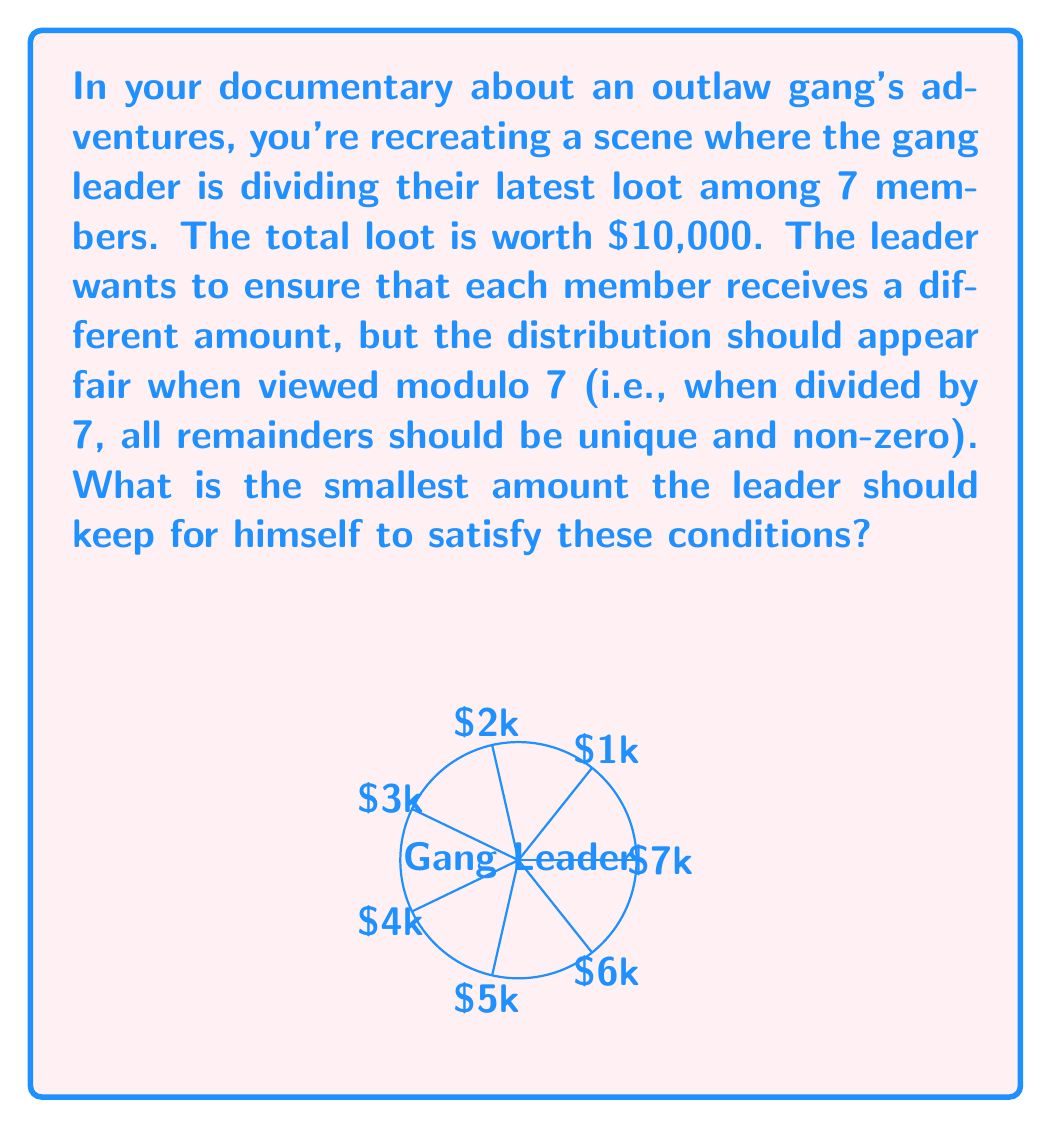What is the answer to this math problem? Let's approach this step-by-step:

1) We need to distribute amounts that, when divided by 7, give unique non-zero remainders. In modular arithmetic, this is expressed as:

   $$x_i \equiv i \pmod{7}, \text{ where } i = 1, 2, 3, 4, 5, 6$$

2) The smallest numbers that satisfy this are:

   $$x_1 = 1, x_2 = 2, x_3 = 3, x_4 = 4, x_5 = 5, x_6 = 6$$

3) However, we're dealing with dollars, so we need to scale these up. The smallest scale factor that works is 1000. So the distribution becomes:

   $$1000, 2000, 3000, 4000, 5000, 6000$$

4) The sum of these amounts is:

   $$1000 + 2000 + 3000 + 4000 + 5000 + 6000 = 21000$$

5) The total loot is $10,000, so the amount the leader keeps is:

   $$10000 - 21000 = -11000$$

6) Since the leader can't distribute more than they have, we need to add $11000 to each amount, including the leader's share:

   $$12000, 13000, 14000, 15000, 16000, 17000$$

   And the leader keeps $0.

7) We can verify that these still satisfy the original condition:

   $$12000 \equiv 1 \pmod{7}, 13000 \equiv 2 \pmod{7}, \text{ and so on}$$

Therefore, the smallest amount the leader can keep while satisfying all conditions is $0.
Answer: $0 